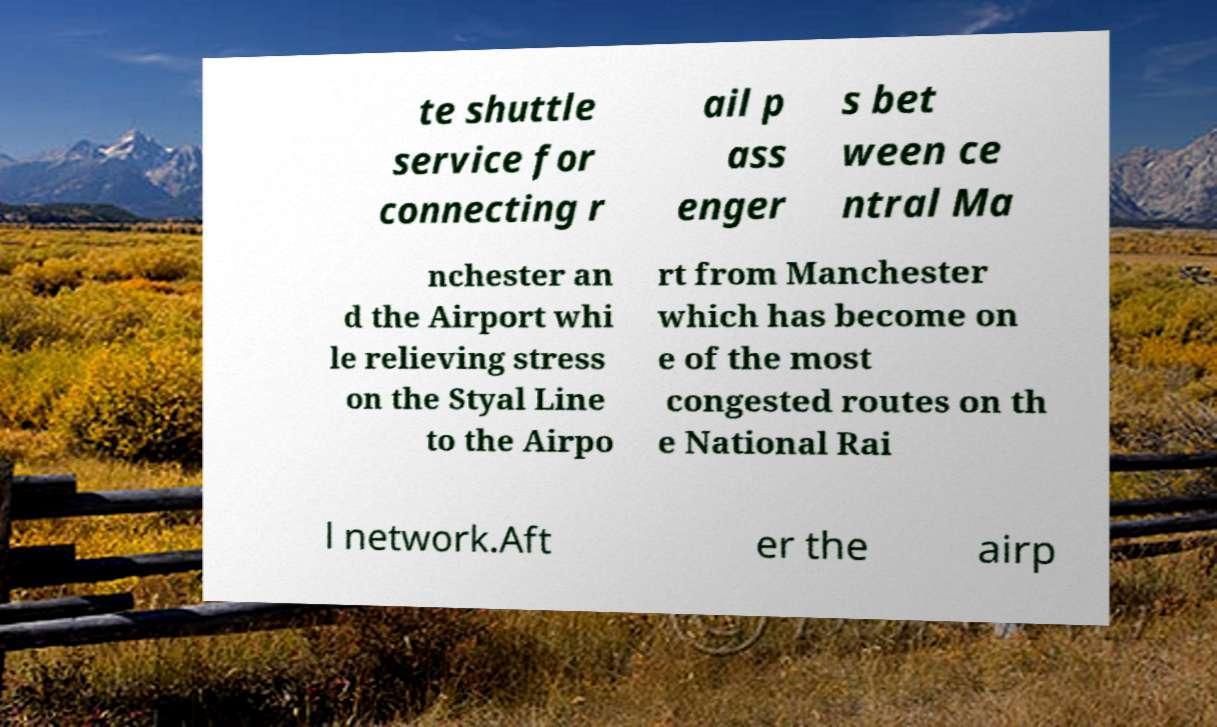Please identify and transcribe the text found in this image. te shuttle service for connecting r ail p ass enger s bet ween ce ntral Ma nchester an d the Airport whi le relieving stress on the Styal Line to the Airpo rt from Manchester which has become on e of the most congested routes on th e National Rai l network.Aft er the airp 